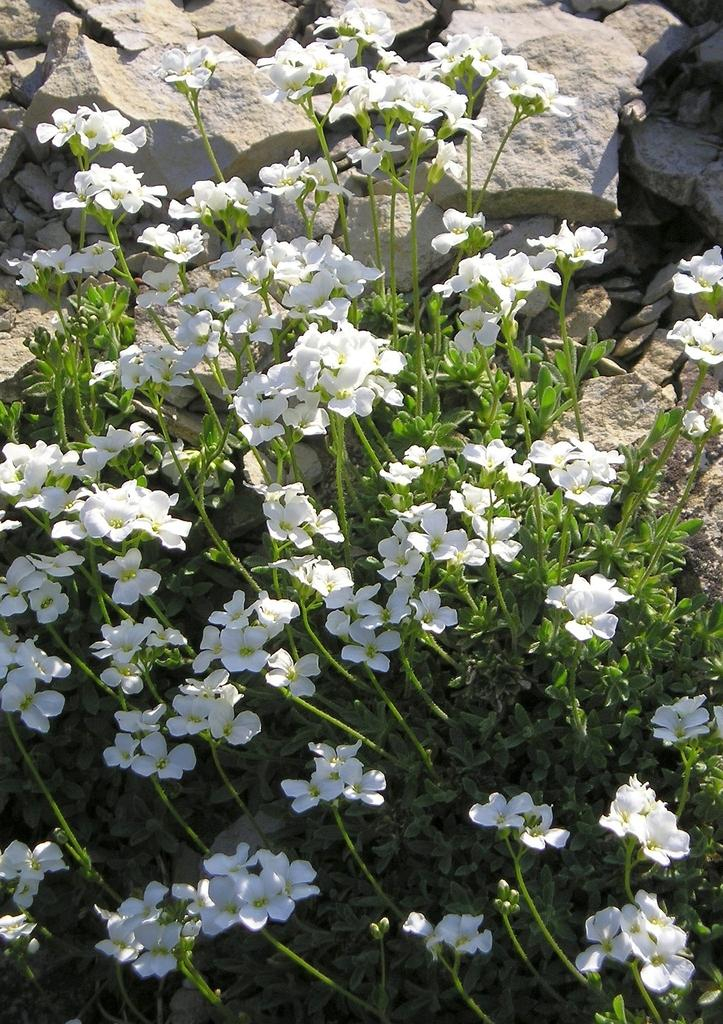What is the main subject of the image? The main subject of the image is plants. What can be seen alongside the plants in the image? There are flowers associated with the plants. What type of natural elements can be seen in the background of the image? There are rocks in the background of the image. What type of pleasure can be seen in the image? There is no indication of pleasure in the image; it features plants, flowers, and rocks. 